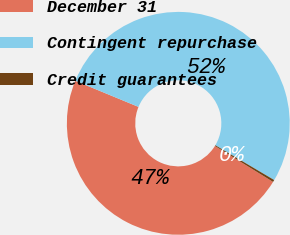Convert chart to OTSL. <chart><loc_0><loc_0><loc_500><loc_500><pie_chart><fcel>December 31<fcel>Contingent repurchase<fcel>Credit guarantees<nl><fcel>47.43%<fcel>52.27%<fcel>0.31%<nl></chart> 